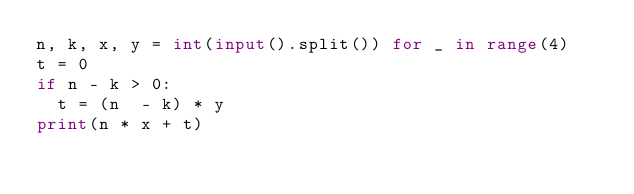<code> <loc_0><loc_0><loc_500><loc_500><_Python_>n, k, x, y = int(input().split()) for _ in range(4)
t = 0
if n - k > 0:
  t = (n  - k) * y
print(n * x + t)</code> 